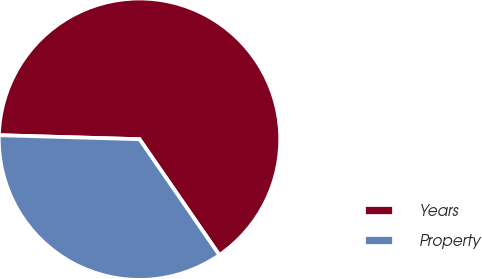<chart> <loc_0><loc_0><loc_500><loc_500><pie_chart><fcel>Years<fcel>Property<nl><fcel>64.94%<fcel>35.06%<nl></chart> 